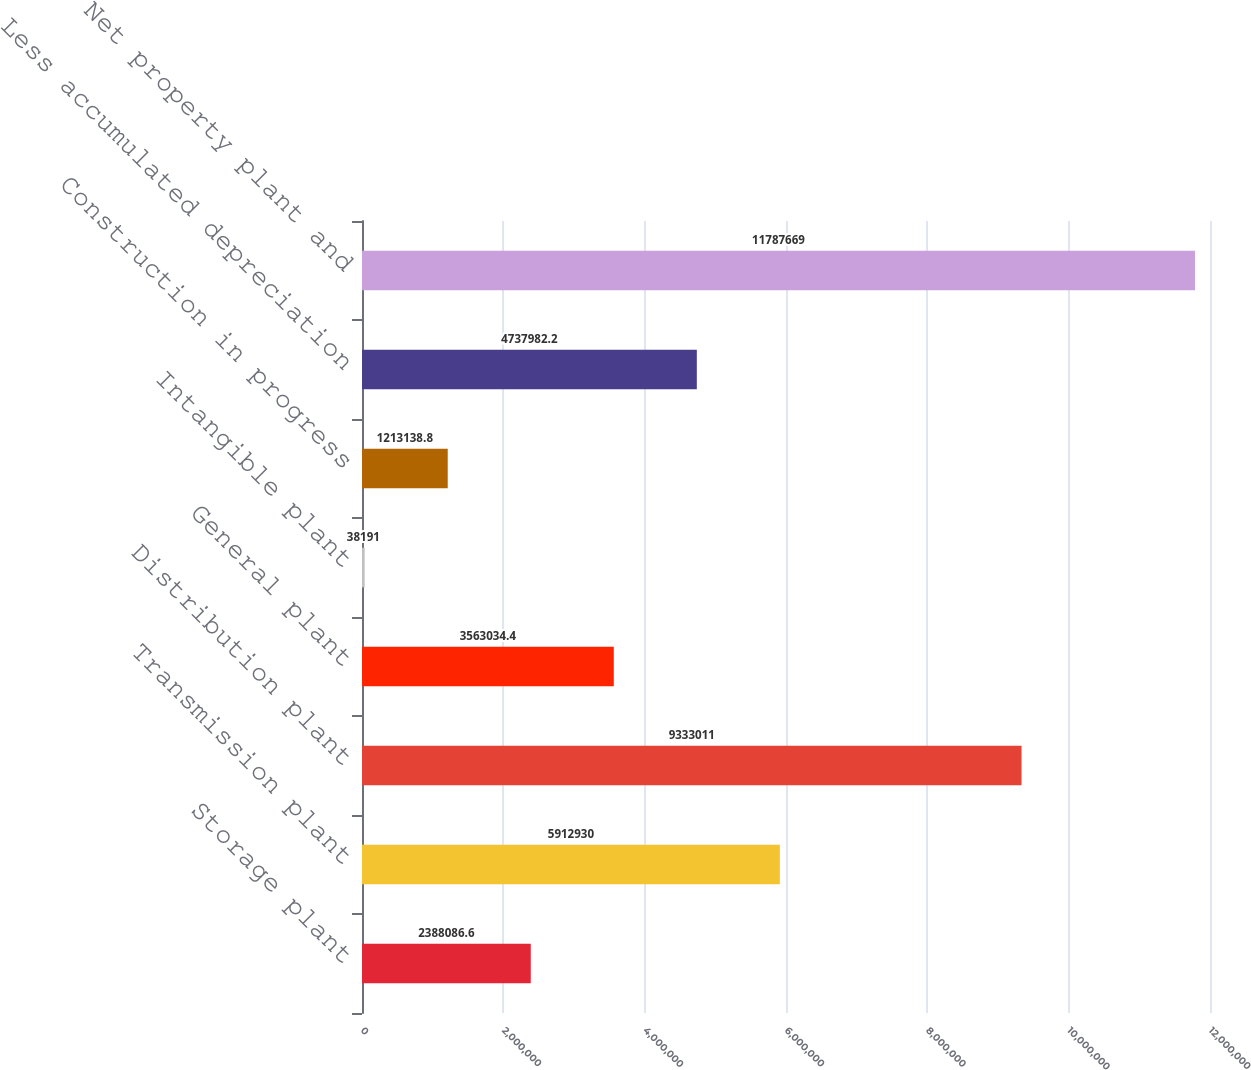Convert chart. <chart><loc_0><loc_0><loc_500><loc_500><bar_chart><fcel>Storage plant<fcel>Transmission plant<fcel>Distribution plant<fcel>General plant<fcel>Intangible plant<fcel>Construction in progress<fcel>Less accumulated depreciation<fcel>Net property plant and<nl><fcel>2.38809e+06<fcel>5.91293e+06<fcel>9.33301e+06<fcel>3.56303e+06<fcel>38191<fcel>1.21314e+06<fcel>4.73798e+06<fcel>1.17877e+07<nl></chart> 